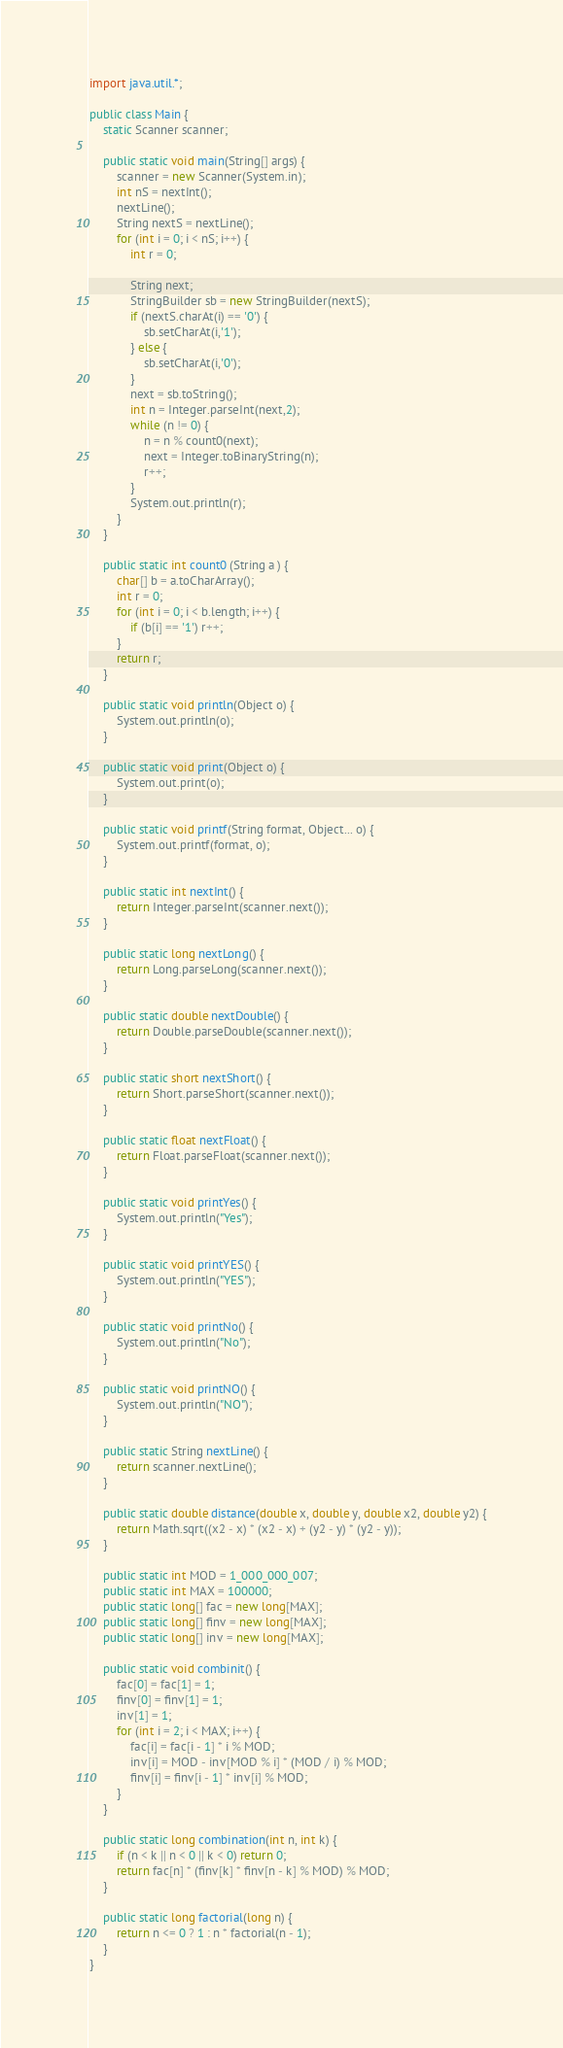Convert code to text. <code><loc_0><loc_0><loc_500><loc_500><_Java_>
import java.util.*;

public class Main {
    static Scanner scanner;

    public static void main(String[] args) {
        scanner = new Scanner(System.in);
        int nS = nextInt();
        nextLine();
        String nextS = nextLine();
        for (int i = 0; i < nS; i++) {
            int r = 0;

            String next;
            StringBuilder sb = new StringBuilder(nextS);
            if (nextS.charAt(i) == '0') {
                sb.setCharAt(i,'1');
            } else {
                sb.setCharAt(i,'0');
            }
            next = sb.toString();
            int n = Integer.parseInt(next,2);
            while (n != 0) {
                n = n % count0(next);
                next = Integer.toBinaryString(n);
                r++;
            }
            System.out.println(r);
        }
    }

    public static int count0 (String a ) {
        char[] b = a.toCharArray();
        int r = 0;
        for (int i = 0; i < b.length; i++) {
            if (b[i] == '1') r++;
        }
        return r;
    }

    public static void println(Object o) {
        System.out.println(o);
    }

    public static void print(Object o) {
        System.out.print(o);
    }

    public static void printf(String format, Object... o) {
        System.out.printf(format, o);
    }

    public static int nextInt() {
        return Integer.parseInt(scanner.next());
    }

    public static long nextLong() {
        return Long.parseLong(scanner.next());
    }

    public static double nextDouble() {
        return Double.parseDouble(scanner.next());
    }

    public static short nextShort() {
        return Short.parseShort(scanner.next());
    }

    public static float nextFloat() {
        return Float.parseFloat(scanner.next());
    }

    public static void printYes() {
        System.out.println("Yes");
    }

    public static void printYES() {
        System.out.println("YES");
    }

    public static void printNo() {
        System.out.println("No");
    }

    public static void printNO() {
        System.out.println("NO");
    }

    public static String nextLine() {
        return scanner.nextLine();
    }

    public static double distance(double x, double y, double x2, double y2) {
        return Math.sqrt((x2 - x) * (x2 - x) + (y2 - y) * (y2 - y));
    }

    public static int MOD = 1_000_000_007;
    public static int MAX = 100000;
    public static long[] fac = new long[MAX];
    public static long[] finv = new long[MAX];
    public static long[] inv = new long[MAX];

    public static void combinit() {
        fac[0] = fac[1] = 1;
        finv[0] = finv[1] = 1;
        inv[1] = 1;
        for (int i = 2; i < MAX; i++) {
            fac[i] = fac[i - 1] * i % MOD;
            inv[i] = MOD - inv[MOD % i] * (MOD / i) % MOD;
            finv[i] = finv[i - 1] * inv[i] % MOD;
        }
    }

    public static long combination(int n, int k) {
        if (n < k || n < 0 || k < 0) return 0;
        return fac[n] * (finv[k] * finv[n - k] % MOD) % MOD;
    }

    public static long factorial(long n) {
        return n <= 0 ? 1 : n * factorial(n - 1);
    }
}</code> 